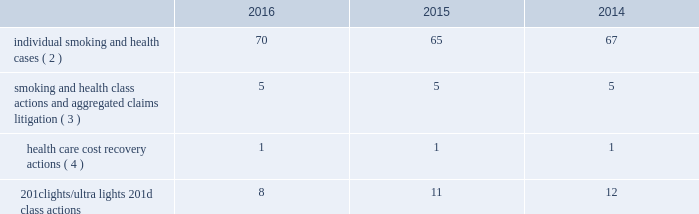Altria group , inc .
And subsidiaries notes to consolidated financial statements _________________________ may not be obtainable in all cases .
This risk has been substantially reduced given that 47 states and puerto rico limit the dollar amount of bonds or require no bond at all .
As discussed below , however , tobacco litigation plaintiffs have challenged the constitutionality of florida 2019s bond cap statute in several cases and plaintiffs may challenge state bond cap statutes in other jurisdictions as well .
Such challenges may include the applicability of state bond caps in federal court .
States , including florida , may also seek to repeal or alter bond cap statutes through legislation .
Although altria group , inc .
Cannot predict the outcome of such challenges , it is possible that the consolidated results of operations , cash flows or financial position of altria group , inc. , or one or more of its subsidiaries , could be materially affected in a particular fiscal quarter or fiscal year by an unfavorable outcome of one or more such challenges .
Altria group , inc .
And its subsidiaries record provisions in the consolidated financial statements for pending litigation when they determine that an unfavorable outcome is probable and the amount of the loss can be reasonably estimated .
At the present time , while it is reasonably possible that an unfavorable outcome in a case may occur , except to the extent discussed elsewhere in this note 19 .
Contingencies : ( i ) management has concluded that it is not probable that a loss has been incurred in any of the pending tobacco-related cases ; ( ii ) management is unable to estimate the possible loss or range of loss that could result from an unfavorable outcome in any of the pending tobacco-related cases ; and ( iii ) accordingly , management has not provided any amounts in the consolidated financial statements for unfavorable outcomes , if any .
Litigation defense costs are expensed as incurred .
Altria group , inc .
And its subsidiaries have achieved substantial success in managing litigation .
Nevertheless , litigation is subject to uncertainty and significant challenges remain .
It is possible that the consolidated results of operations , cash flows or financial position of altria group , inc. , or one or more of its subsidiaries , could be materially affected in a particular fiscal quarter or fiscal year by an unfavorable outcome or settlement of certain pending litigation .
Altria group , inc .
And each of its subsidiaries named as a defendant believe , and each has been so advised by counsel handling the respective cases , that it has valid defenses to the litigation pending against it , as well as valid bases for appeal of adverse verdicts .
Each of the companies has defended , and will continue to defend , vigorously against litigation challenges .
However , altria group , inc .
And its subsidiaries may enter into settlement discussions in particular cases if they believe it is in the best interests of altria group , inc .
To do so .
Overview of altria group , inc .
And/or pm usa tobacco- related litigation types and number of cases : claims related to tobacco products generally fall within the following categories : ( i ) smoking and health cases alleging personal injury brought on behalf of individual plaintiffs ; ( ii ) smoking and health cases primarily alleging personal injury or seeking court-supervised programs for ongoing medical monitoring and purporting to be brought on behalf of a class of individual plaintiffs , including cases in which the aggregated claims of a number of individual plaintiffs are to be tried in a single proceeding ; ( iii ) health care cost recovery cases brought by governmental ( both domestic and foreign ) plaintiffs seeking reimbursement for health care expenditures allegedly caused by cigarette smoking and/or disgorgement of profits ; ( iv ) class action suits alleging that the uses of the terms 201clights 201d and 201cultra lights 201d constitute deceptive and unfair trade practices , common law or statutory fraud , unjust enrichment , breach of warranty or violations of the racketeer influenced and corrupt organizations act ( 201crico 201d ) ; and ( v ) other tobacco-related litigation described below .
Plaintiffs 2019 theories of recovery and the defenses raised in pending smoking and health , health care cost recovery and 201clights/ultra lights 201d cases are discussed below .
The table below lists the number of certain tobacco-related cases pending in the united states against pm usa ( 1 ) and , in some instances , altria group , inc .
As of december 31 , 2016 , 2015 and 2014: .
( 1 ) does not include 25 cases filed on the asbestos docket in the circuit court for baltimore city , maryland , which seek to join pm usa and other cigarette- manufacturing defendants in complaints previously filed against asbestos companies .
( 2 ) does not include 2485 cases brought by flight attendants seeking compensatory damages for personal injuries allegedly caused by exposure to environmental tobacco smoke ( 201cets 201d ) .
The flight attendants allege that they are members of an ets smoking and health class action in florida , which was settled in 1997 ( broin ) .
The terms of the court-approved settlement in that case allowed class members to file individual lawsuits seeking compensatory damages , but prohibited them from seeking punitive damages .
Also , does not include individual smoking and health cases brought by or on behalf of plaintiffs in florida state and federal courts following the decertification of the engle case ( discussed below in smoking and health litigation - engle class action ) .
( 3 ) includes as one case the 600 civil actions ( of which 344 were actions against pm usa ) that were to be tried in a single proceeding in west virginia ( in re : tobacco litigation ) .
The west virginia supreme court of appeals ruled that the united states constitution did not preclude a trial in two phases in this case .
Issues related to defendants 2019 conduct and whether punitive damages are permissible were tried in the first phase .
Trial in the first phase of this case began in april 2013 .
In may 2013 , the jury returned a verdict in favor of defendants on the claims for design defect , negligence , failure to warn , breach of warranty , and concealment and declined to find that the defendants 2019 conduct warranted punitive damages .
Plaintiffs prevailed on their claim that ventilated filter cigarettes should have included use instructions for the period 1964 - 1969 .
The second phase will consist of trials to determine liability and compensatory damages .
In november 2014 , the west virginia supreme court of appeals affirmed the final judgment .
In july 2015 , the trial court entered an order that will result in the entry of final judgment in favor of defendants and against all but 30 plaintiffs who potentially have a claim against one or more defendants that may be pursued in a second phase of trial .
The court intends to try the claims of these 30 plaintiffs in six consolidated trials , each with a group of five plaintiffs .
The first trial is currently scheduled to begin may 1 , 2018 .
Dates for the five remaining consolidated trials have not been scheduled .
( 4 ) see health care cost recovery litigation - federal government 2019s lawsuit below. .
What are the total number of pending tobacco-related cases in united states in 2014? 
Computations: (((67 + 5) + 1) + 12)
Answer: 85.0. 